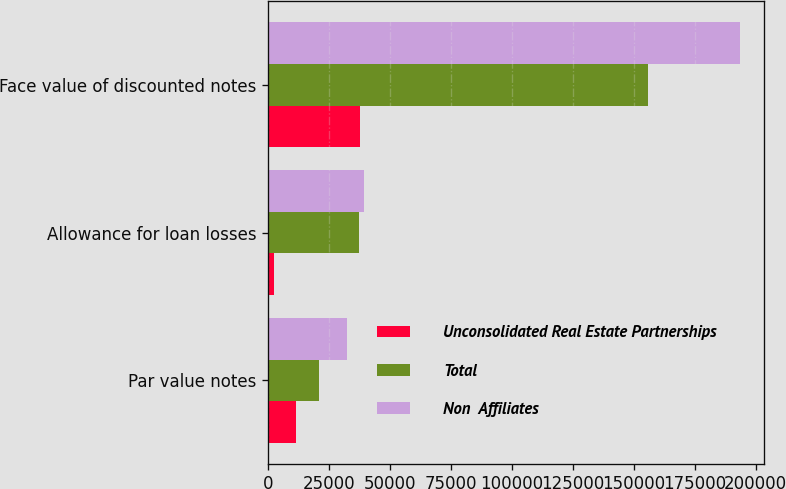Convert chart. <chart><loc_0><loc_0><loc_500><loc_500><stacked_bar_chart><ecel><fcel>Par value notes<fcel>Allowance for loan losses<fcel>Face value of discounted notes<nl><fcel>Unconsolidated Real Estate Partnerships<fcel>11353<fcel>2153<fcel>37709<nl><fcel>Total<fcel>20862<fcel>37061<fcel>155848<nl><fcel>Non  Affiliates<fcel>32215<fcel>39214<fcel>193557<nl></chart> 